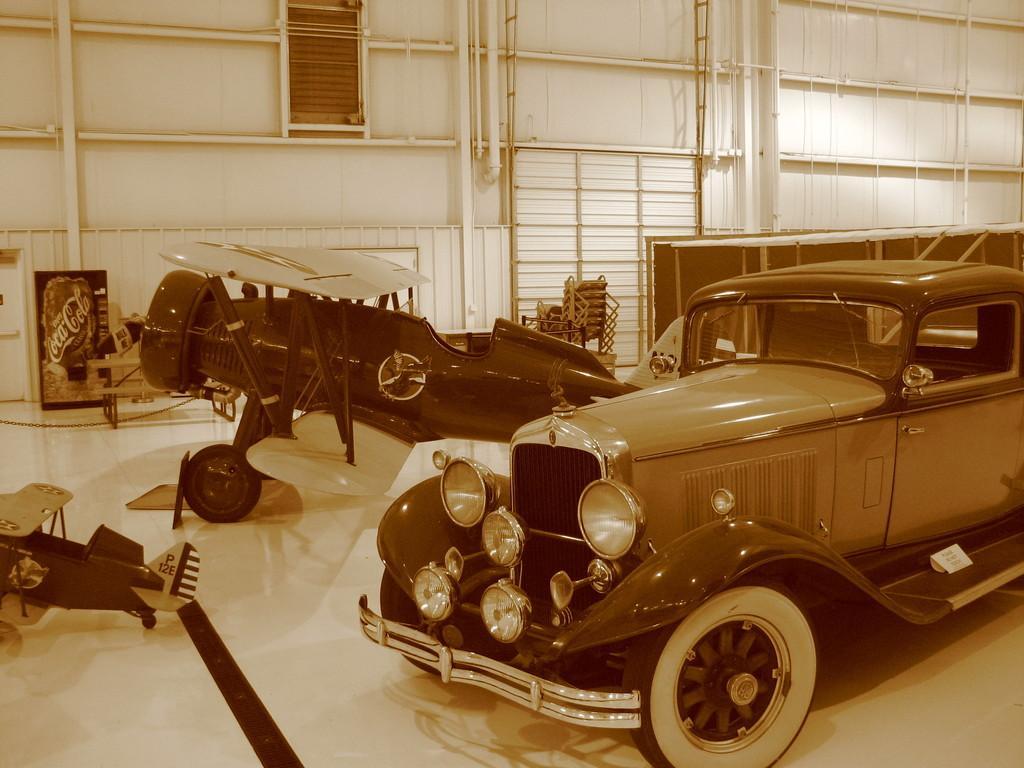In one or two sentences, can you explain what this image depicts? In this image, I can see an aircraft and a car. This looks like a hoarding. I think this is a bench. Here is the wall with the pipes attached to it. On the left side of the image, I can see a small aircraft. 